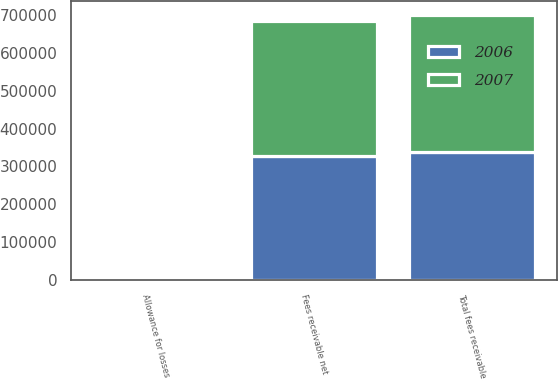Convert chart to OTSL. <chart><loc_0><loc_0><loc_500><loc_500><stacked_bar_chart><ecel><fcel>Total fees receivable<fcel>Allowance for losses<fcel>Fees receivable net<nl><fcel>2007<fcel>363376<fcel>8450<fcel>354926<nl><fcel>2006<fcel>337083<fcel>8700<fcel>328383<nl></chart> 